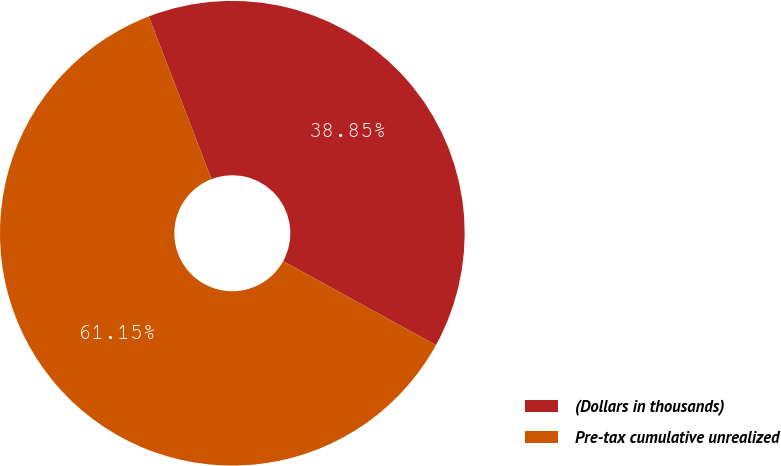Convert chart. <chart><loc_0><loc_0><loc_500><loc_500><pie_chart><fcel>(Dollars in thousands)<fcel>Pre-tax cumulative unrealized<nl><fcel>38.85%<fcel>61.15%<nl></chart> 